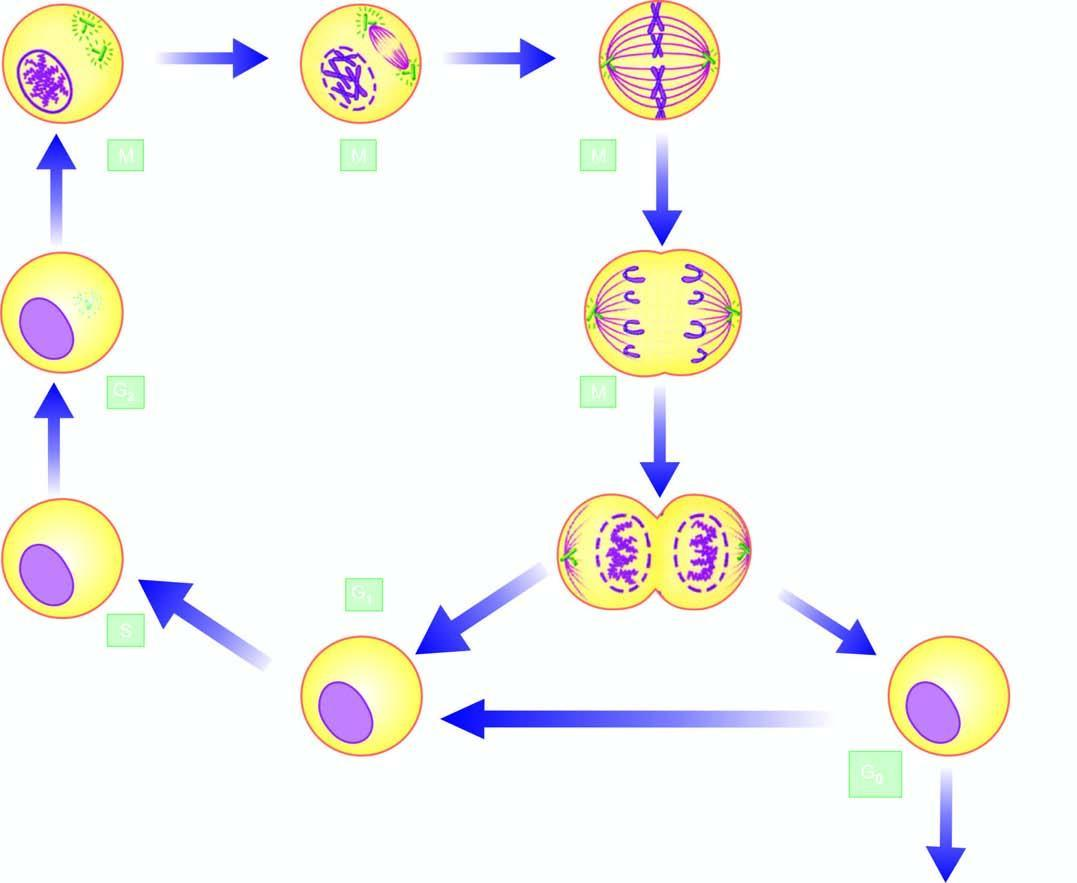how many daughter cells are formed which may continue to remain in the cell cycle or go out of it in resting phase interphase, the g0 phase on completion of cell division?
Answer the question using a single word or phrase. Two 